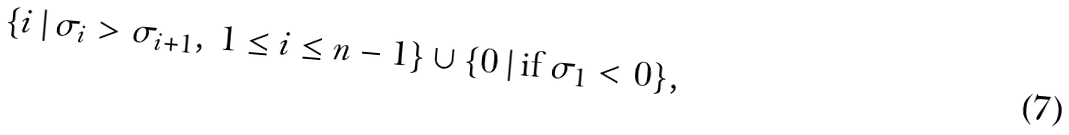<formula> <loc_0><loc_0><loc_500><loc_500>\{ i \, | \, \sigma _ { i } > \sigma _ { i + 1 } , \, 1 \leq i \leq n - 1 \} \cup \{ 0 \, | \, \text {if $\sigma_{1}<0$} \} ,</formula> 